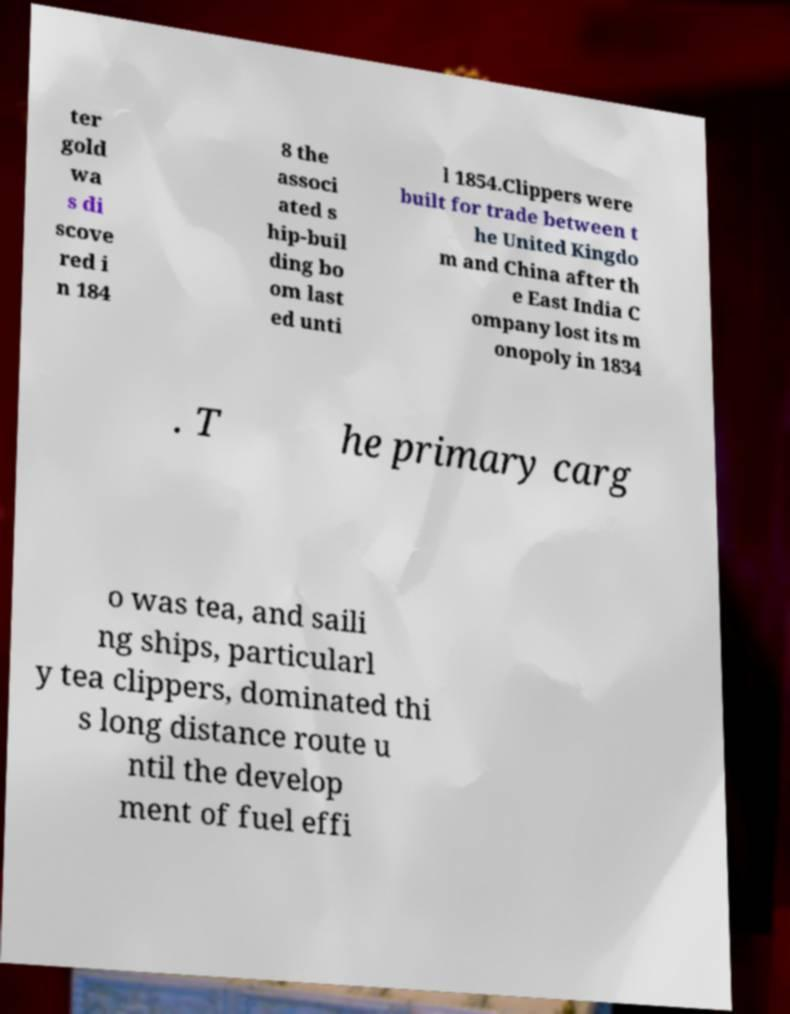I need the written content from this picture converted into text. Can you do that? ter gold wa s di scove red i n 184 8 the associ ated s hip-buil ding bo om last ed unti l 1854.Clippers were built for trade between t he United Kingdo m and China after th e East India C ompany lost its m onopoly in 1834 . T he primary carg o was tea, and saili ng ships, particularl y tea clippers, dominated thi s long distance route u ntil the develop ment of fuel effi 